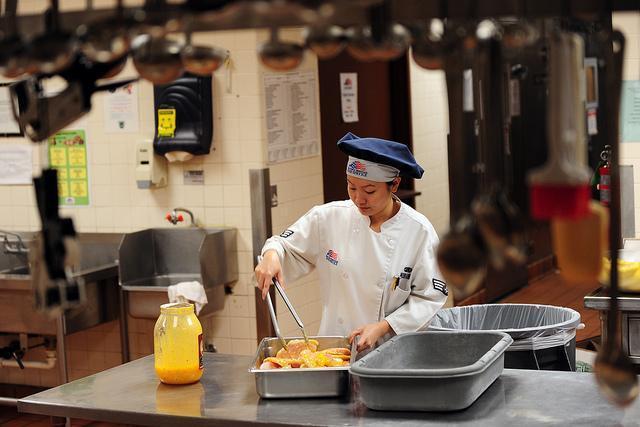How many people are in this room?
Give a very brief answer. 1. 